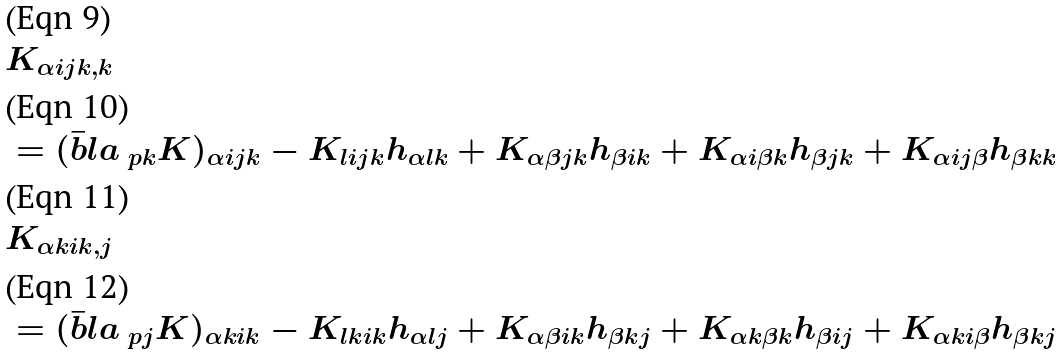Convert formula to latex. <formula><loc_0><loc_0><loc_500><loc_500>& K _ { \alpha i j k , k } \\ & = ( \bar { b } l a _ { \ p k } K ) _ { \alpha i j k } - K _ { l i j k } h _ { \alpha l k } + K _ { \alpha \beta j k } h _ { \beta i k } + K _ { \alpha i \beta k } h _ { \beta j k } + K _ { \alpha i j \beta } h _ { \beta k k } \\ & K _ { \alpha k i k , j } \\ & = ( \bar { b } l a _ { \ p j } K ) _ { \alpha k i k } - K _ { l k i k } h _ { \alpha l j } + K _ { \alpha \beta i k } h _ { \beta k j } + K _ { \alpha k \beta k } h _ { \beta i j } + K _ { \alpha k i \beta } h _ { \beta k j }</formula> 